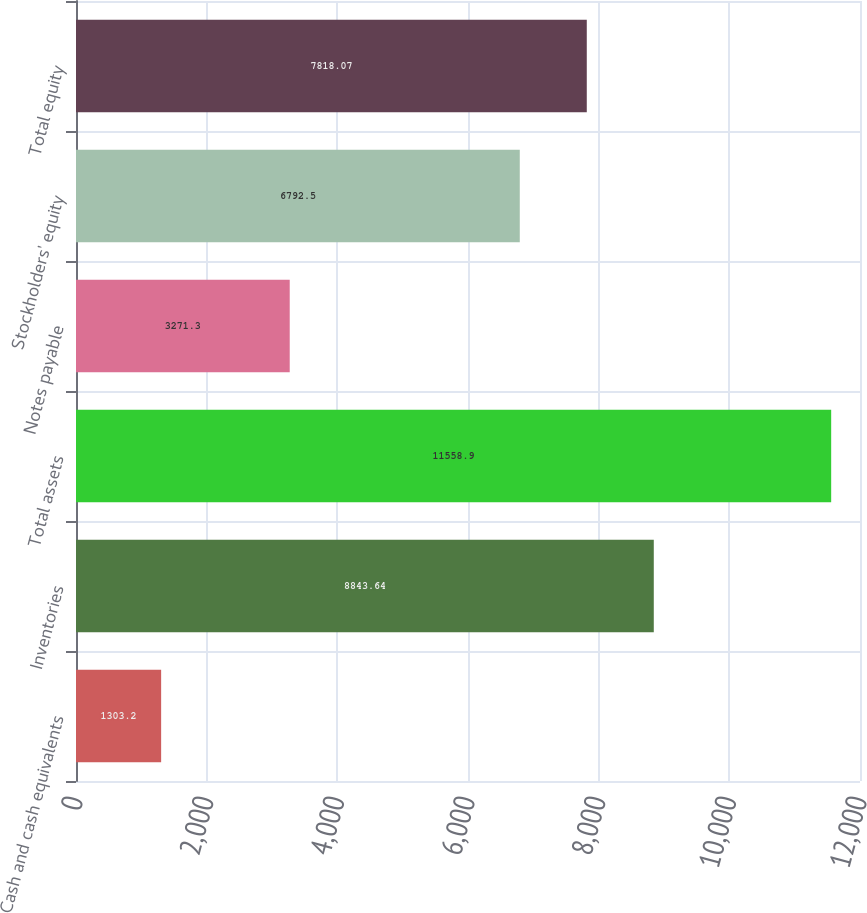<chart> <loc_0><loc_0><loc_500><loc_500><bar_chart><fcel>Cash and cash equivalents<fcel>Inventories<fcel>Total assets<fcel>Notes payable<fcel>Stockholders' equity<fcel>Total equity<nl><fcel>1303.2<fcel>8843.64<fcel>11558.9<fcel>3271.3<fcel>6792.5<fcel>7818.07<nl></chart> 